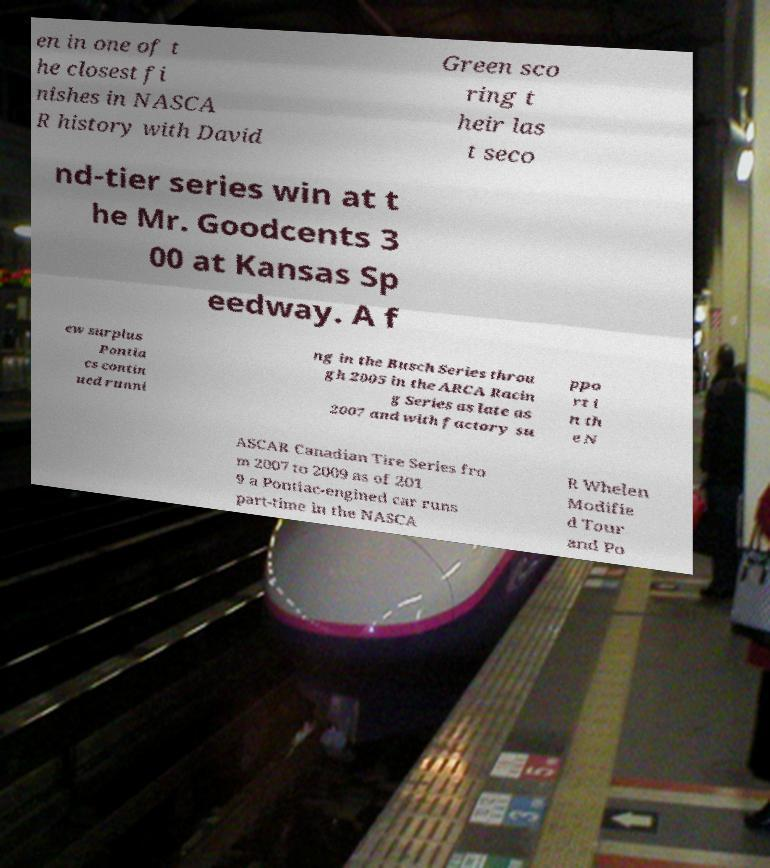Can you read and provide the text displayed in the image?This photo seems to have some interesting text. Can you extract and type it out for me? en in one of t he closest fi nishes in NASCA R history with David Green sco ring t heir las t seco nd-tier series win at t he Mr. Goodcents 3 00 at Kansas Sp eedway. A f ew surplus Pontia cs contin ued runni ng in the Busch Series throu gh 2005 in the ARCA Racin g Series as late as 2007 and with factory su ppo rt i n th e N ASCAR Canadian Tire Series fro m 2007 to 2009 as of 201 9 a Pontiac-engined car runs part-time in the NASCA R Whelen Modifie d Tour and Po 